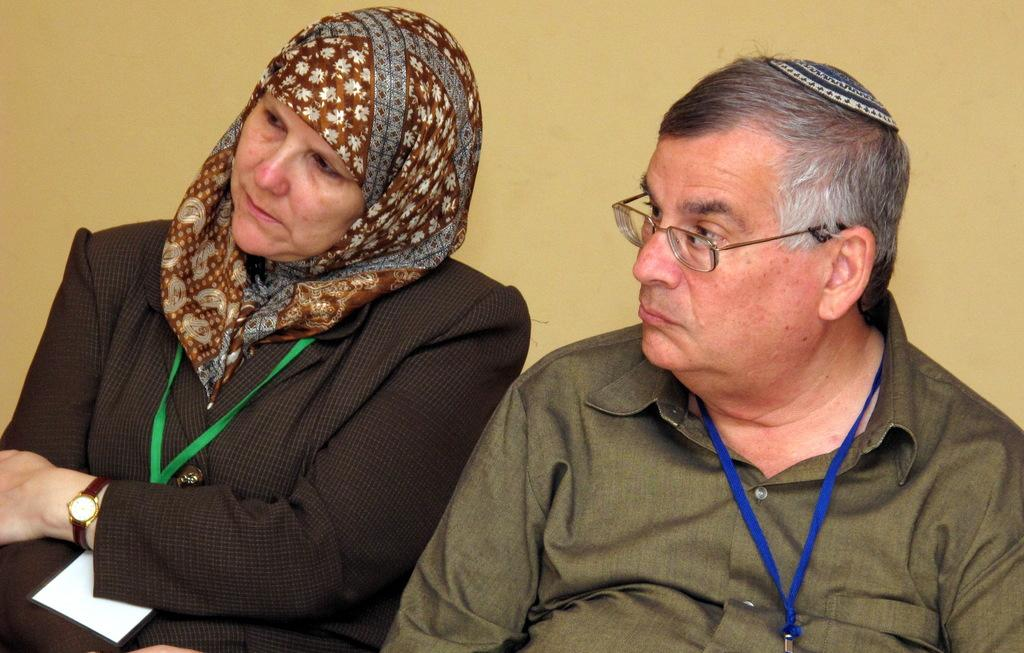How many people are visible in the image? There are two persons in the image. Where are the two persons located in relation to the image? The two persons are in front. What is located behind the two persons? There is a wall behind the two persons. What is the opinion of the wall in the image? The wall does not have an opinion, as it is an inanimate object. 